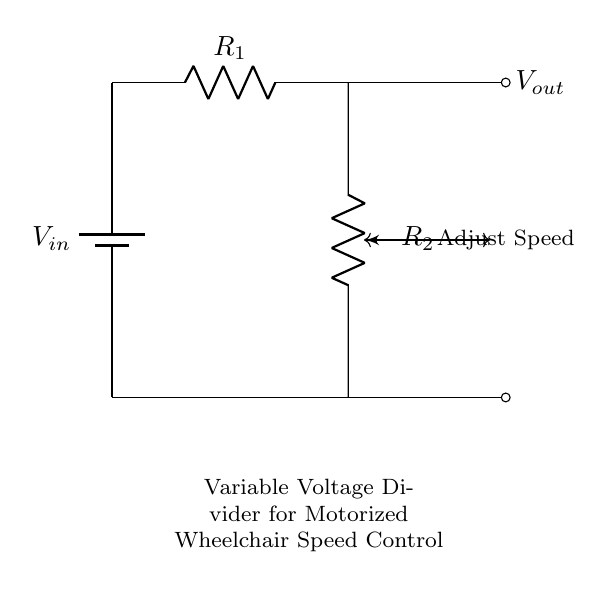What is the input voltage of this circuit? The input voltage, represented by $V_{in}$ in the circuit, is connected to the battery symbol at the top left corner of the diagram. Since the battery's actual voltage is not specified in the circuit, we cannot quantify it here.
Answer: $V_{in}$ What component is used to adjust the output voltage? The component used to adjust the output voltage is labeled as $R_2$, which is depicted as a potentiometer in the circuit diagram. A potentiometer varies the resistance and consequently alters the output voltage.
Answer: Potentiometer What are the two resistances in this circuit? The two resistances present in the voltage divider circuit are $R_1$ and $R_2$. $R_1$ is a fixed resistor, while $R_2$ is a variable resistor (potentiometer) that can be adjusted.
Answer: $R_1$ and $R_2$ What is the function of the voltage divider in this circuit? The function of the voltage divider, particularly in this context, is to supply a controlled output voltage ($V_{out}$) from a higher input voltage ($V_{in}$). This is useful for controlling motor speed in motorized wheelchairs.
Answer: Speed control How can you increase the output voltage in this circuit? To increase the output voltage, one would need to decrease the resistance value of the potentiometer $R_2$, which allows more voltage to drop across it according to the voltage divider equation.
Answer: Decrease $R_2$ What does the dashed line towards $V_{out}$ indicate? The dashed line leading to $V_{out}$ indicates the output connection point where the voltage is taken from the circuit. This is the voltage that is used to control the speed of the wheelchair.
Answer: Output connection 